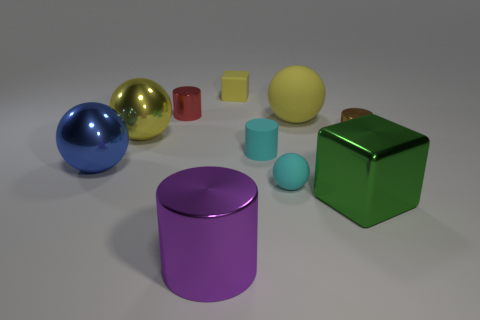Subtract all cyan blocks. How many yellow spheres are left? 2 Subtract all blue spheres. How many spheres are left? 3 Subtract all tiny cyan cylinders. How many cylinders are left? 3 Subtract all spheres. How many objects are left? 6 Subtract all cyan cylinders. Subtract all cyan cubes. How many cylinders are left? 3 Subtract all yellow matte cubes. Subtract all small gray spheres. How many objects are left? 9 Add 4 small matte things. How many small matte things are left? 7 Add 2 large cylinders. How many large cylinders exist? 3 Subtract 0 green balls. How many objects are left? 10 